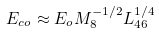<formula> <loc_0><loc_0><loc_500><loc_500>E _ { c o } \approx E _ { o } M _ { 8 } ^ { - 1 / 2 } L _ { 4 6 } ^ { 1 / 4 }</formula> 